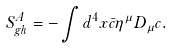<formula> <loc_0><loc_0><loc_500><loc_500>S _ { g h } ^ { A } = - \int d ^ { 4 } x \bar { c } \eta ^ { \mu } D _ { \mu } c .</formula> 